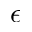<formula> <loc_0><loc_0><loc_500><loc_500>\epsilon</formula> 